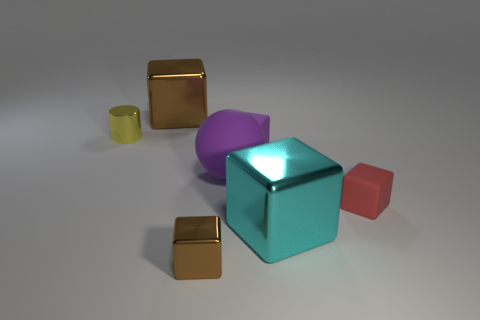Could you describe the arrangement of the objects in relation to each other? Certainly. Centrally placed is a large, shiny blue cube. Flanking it to the right is a smaller matte pink cube, and to the left, a tiny yellow cylinder. Behind the central blue cube, a matte purple shape is barely visible, and in the lower left corner, two reflective gold cubes are neatly positioned, with one slightly staggered in front of the other. What feeling or atmosphere does the combination of these objects and colors invoke? The objects and colors create a somewhat playful and whimsical atmosphere. The use of bright, primary colors combined with the simplicity of the shapes gives the scene a clean, almost toy-like aesthetic. 